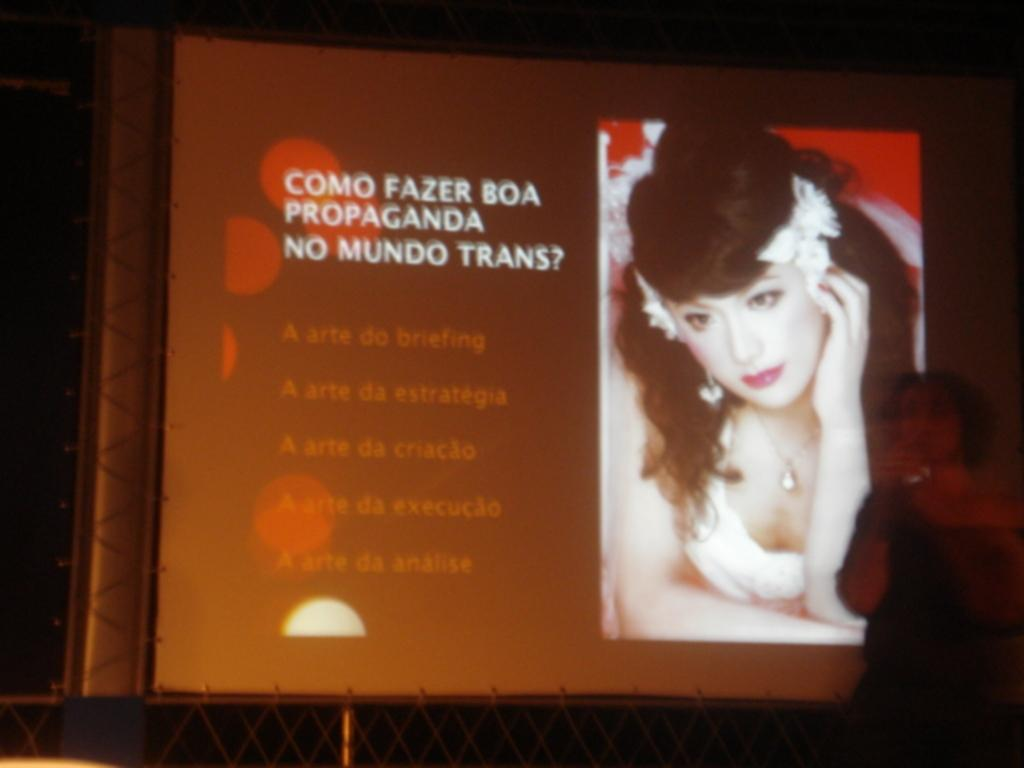Who or what is on the right side of the image? There is a person standing on the right side of the image. What is the board with text in the image used for? The board with text in the image is likely used for conveying information or displaying a message. What is depicted on the board? There is a picture of a person on the board. How would you describe the overall lighting in the image? The background of the image is dark. Where is the wrench placed on the shelf in the image? There is no wrench or shelf present in the image. What type of star can be seen in the image? There is no star visible in the image. 